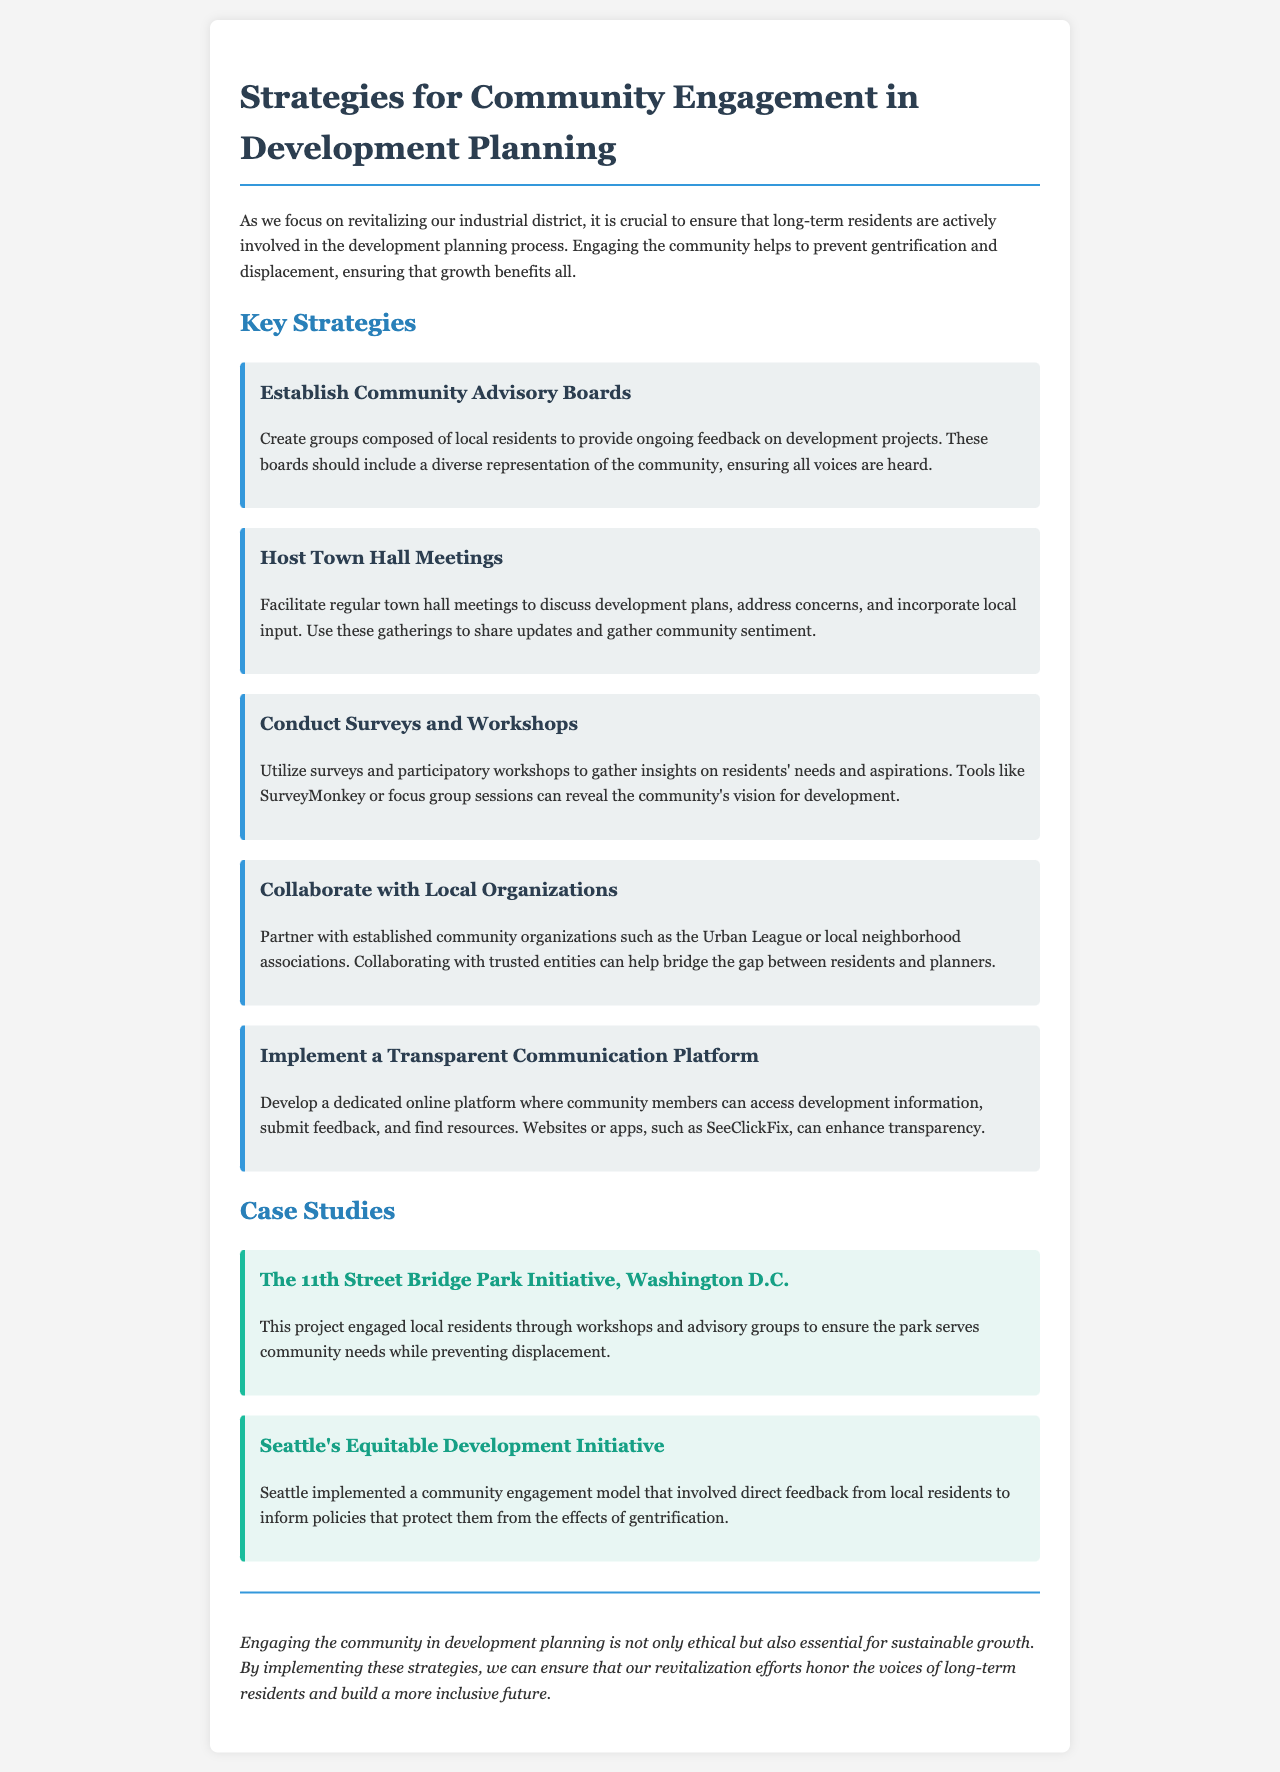What is the main purpose of the brochure? The brochure aims to emphasize the importance of community engagement in development planning to prevent gentrification and displacement of long-term residents.
Answer: community engagement What strategy involves local residents providing feedback? This strategy is designed to create ongoing dialogue between local residents and developers, ensuring diverse community representation.
Answer: Community Advisory Boards How many case studies are presented in the brochure? The brochure highlights two specific projects that exemplify effective community engagement in development.
Answer: 2 What type of meetings are recommended to gather local input? These meetings are a platform for discussing plans, listening to concerns, and sharing updates with the community.
Answer: Town Hall Meetings Which initiative in Washington D.C. focuses on resident engagement? This initiative is specifically mentioned as a case study that involved local residents in planning to meet community needs.
Answer: The 11th Street Bridge Park Initiative What tool is suggested for gathering insights from residents? This method allows for the collection of feedback and opinions from community members about their needs and aspirations.
Answer: Surveys and Workshops What is one benefit of collaborating with local organizations? Partnering with established groups can help improve communication and trust between residents and planners.
Answer: trust What does the brochure suggest for communicating with the community? Developing this platform ensures that residents can easily access information and provide feedback about development projects.
Answer: Transparent Communication Platform What is the concluding message of the brochure? The conclusion emphasizes the ethical and essential nature of community engagement for sustainable growth.
Answer: sustainable growth 